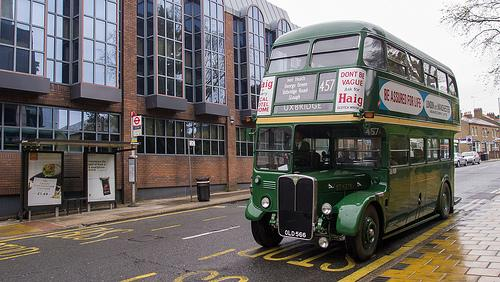Analyze the image and point out any element that might require attention in an anomaly detection task. The unusual yellow sidewalk and the leafless tree might require attention in an anomaly detection task. Discuss the status of the street and its lines in the image. The street has yellow lines and a white line, indicating traffic lanes and stop positions. Explain an interaction between two objects in the image that contributes to its context. The bus stop on the sidewalk provides context for the green double-decker bus driving down the city street. Identify the central object in the image and elaborate on its presence on the street. A green double-decker bus with advertisements and the number 457 is the central object, driving down a city street with parked cars. List three elements found on or around the sidewalk in the image. A bus stop, a trash can, and a sign posted next to a bus stop are found on the sidewalk. What type of public transport is mainly featured in the image, and what color is it? A green double-decker bus with a yellow stripe is driving down a city street. Observe the image and mention a significant feature about the building behind the bus. The building has big windows on two rows, and the windows are reflecting a tree. Describe two notable elements related to traffic signs and indicators in the image. There are red and white street signs and the word "stop" is written in yellow on the tar road near the bus. Could you explain the condition of the pavement and a crucial detail signifying it? The sidewalk is yellow with yellow brick patterns, and there is a black trash can next to a pole. Examine the image carefully and point out three distinctive features of the bus. The bus features a curved roof, white round headlights, and windows reflecting a tree. 